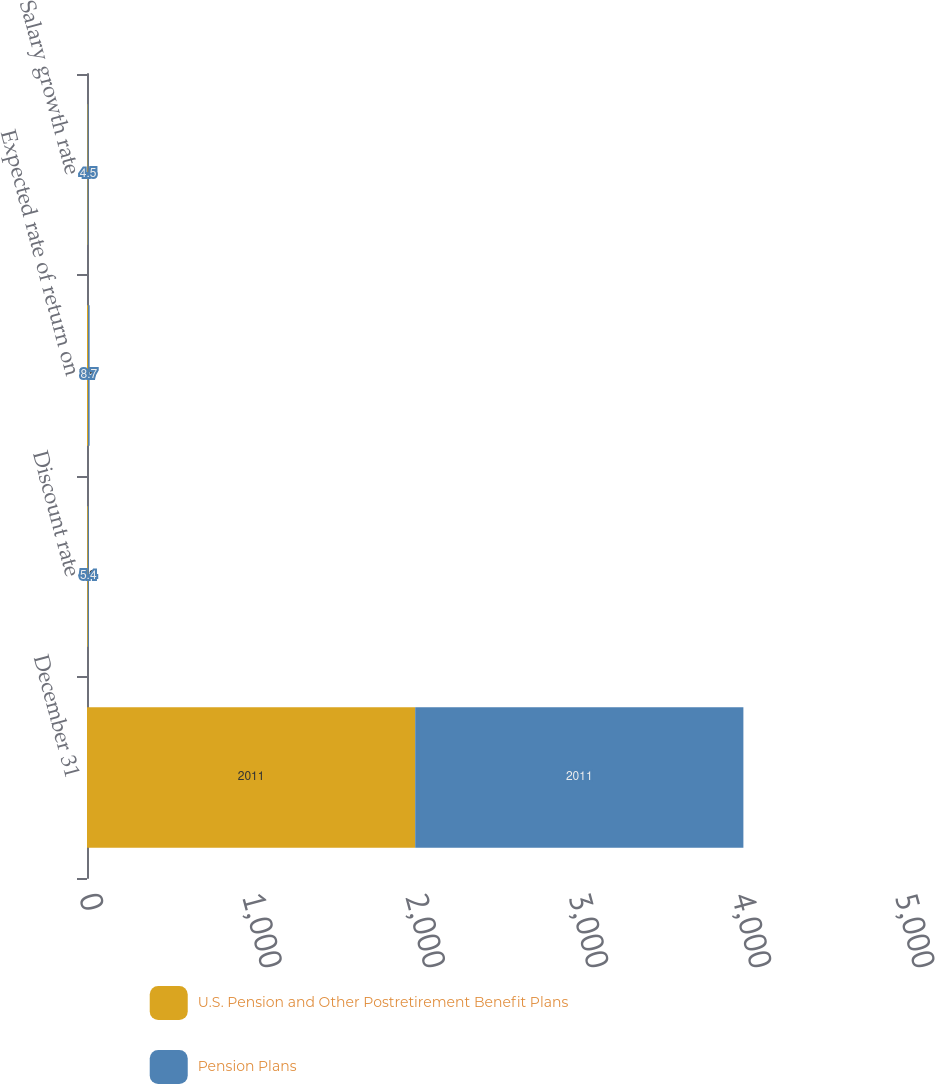Convert chart to OTSL. <chart><loc_0><loc_0><loc_500><loc_500><stacked_bar_chart><ecel><fcel>December 31<fcel>Discount rate<fcel>Expected rate of return on<fcel>Salary growth rate<nl><fcel>U.S. Pension and Other Postretirement Benefit Plans<fcel>2011<fcel>5.2<fcel>7.5<fcel>4.2<nl><fcel>Pension Plans<fcel>2011<fcel>5.4<fcel>8.7<fcel>4.5<nl></chart> 